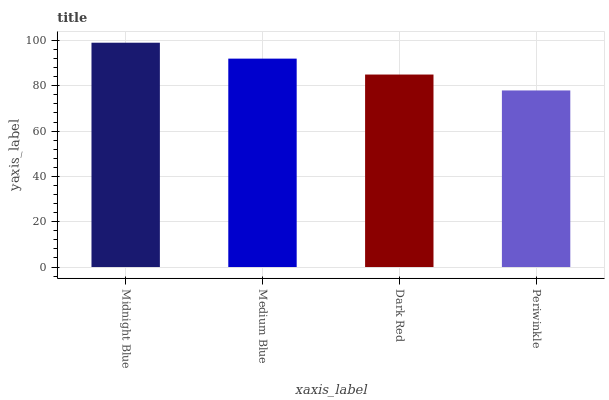Is Periwinkle the minimum?
Answer yes or no. Yes. Is Midnight Blue the maximum?
Answer yes or no. Yes. Is Medium Blue the minimum?
Answer yes or no. No. Is Medium Blue the maximum?
Answer yes or no. No. Is Midnight Blue greater than Medium Blue?
Answer yes or no. Yes. Is Medium Blue less than Midnight Blue?
Answer yes or no. Yes. Is Medium Blue greater than Midnight Blue?
Answer yes or no. No. Is Midnight Blue less than Medium Blue?
Answer yes or no. No. Is Medium Blue the high median?
Answer yes or no. Yes. Is Dark Red the low median?
Answer yes or no. Yes. Is Dark Red the high median?
Answer yes or no. No. Is Medium Blue the low median?
Answer yes or no. No. 